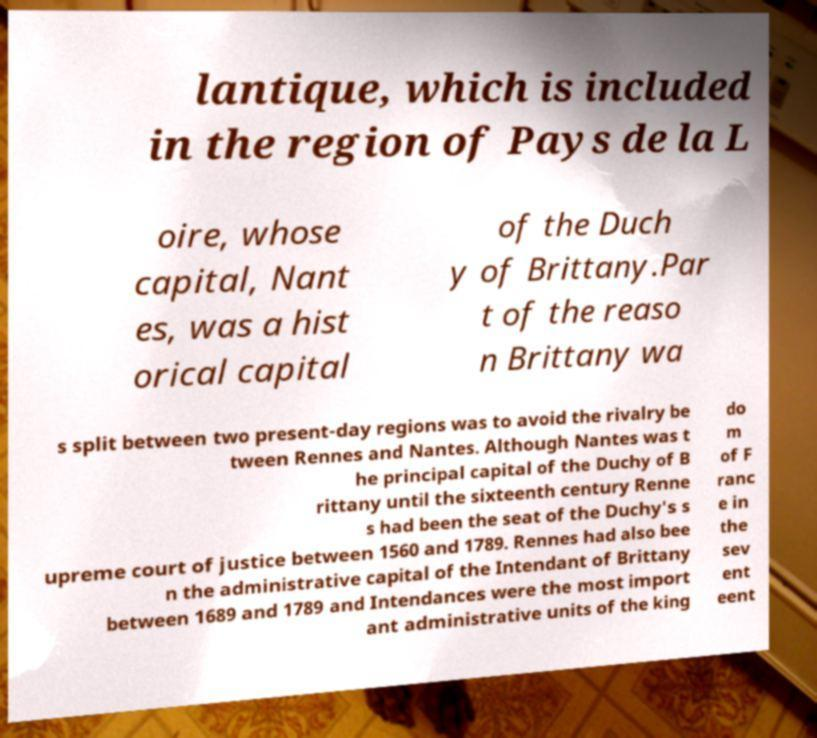I need the written content from this picture converted into text. Can you do that? lantique, which is included in the region of Pays de la L oire, whose capital, Nant es, was a hist orical capital of the Duch y of Brittany.Par t of the reaso n Brittany wa s split between two present-day regions was to avoid the rivalry be tween Rennes and Nantes. Although Nantes was t he principal capital of the Duchy of B rittany until the sixteenth century Renne s had been the seat of the Duchy's s upreme court of justice between 1560 and 1789. Rennes had also bee n the administrative capital of the Intendant of Brittany between 1689 and 1789 and Intendances were the most import ant administrative units of the king do m of F ranc e in the sev ent eent 